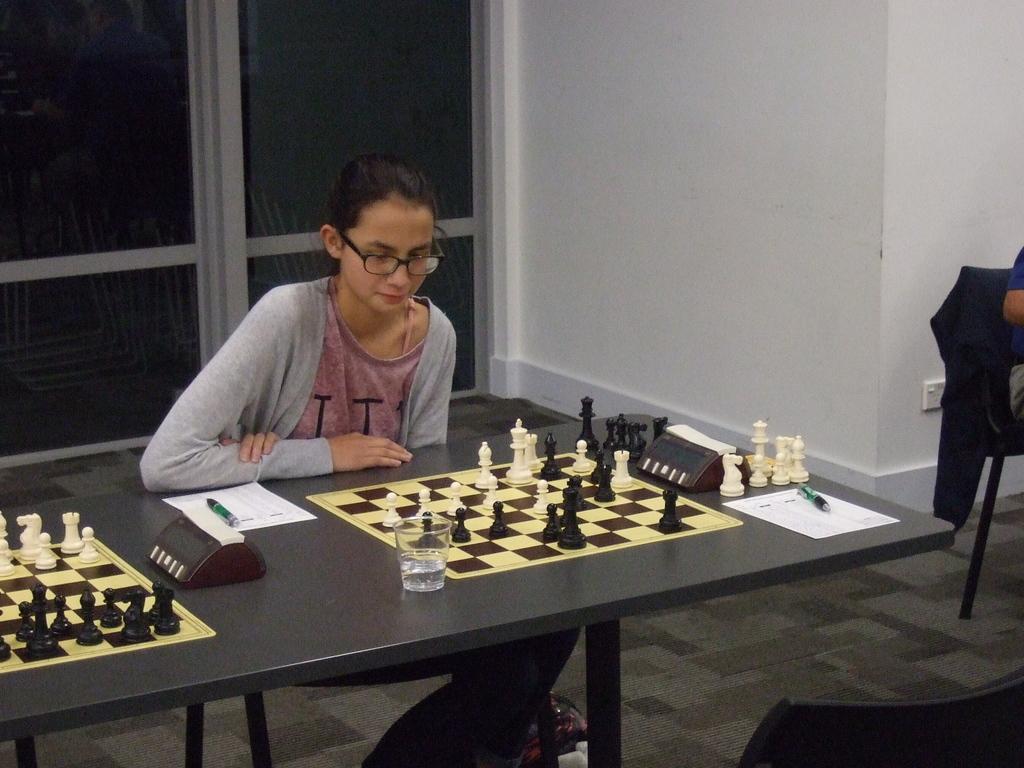In one or two sentences, can you explain what this image depicts? A lady wearing specs is sitting and looking into the chess board. On the table there are two chess boards, coins, timers, pen, paper and glasses. In the background there is a door, wall, sockets. 